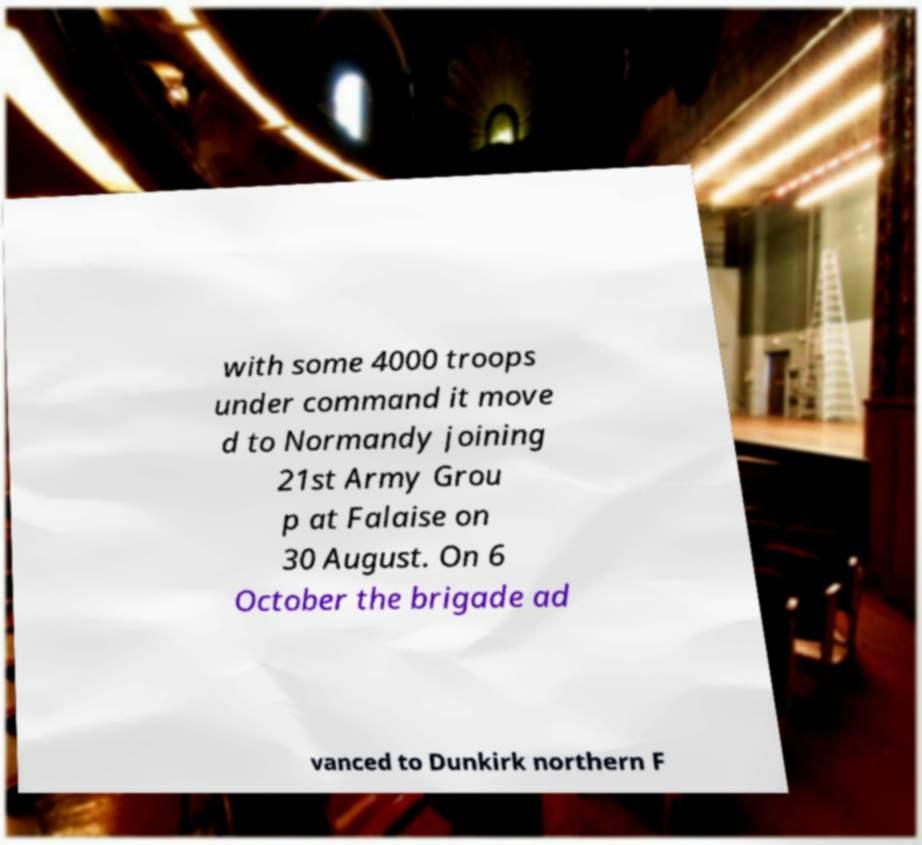Please read and relay the text visible in this image. What does it say? with some 4000 troops under command it move d to Normandy joining 21st Army Grou p at Falaise on 30 August. On 6 October the brigade ad vanced to Dunkirk northern F 